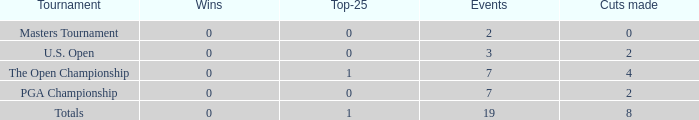What is the lowest Top-25 with Wins less than 0? None. 